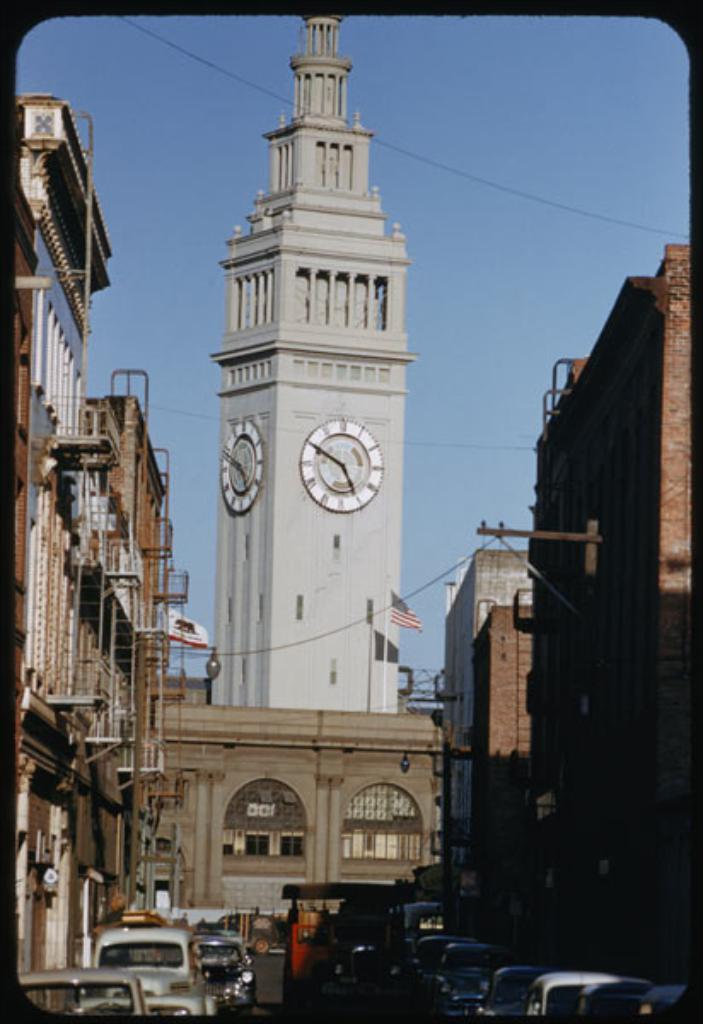In one or two sentences, can you explain what this image depicts? In this image in front there are vehicles on the road. There are buildings, flags. In the background of the image there is sky. 